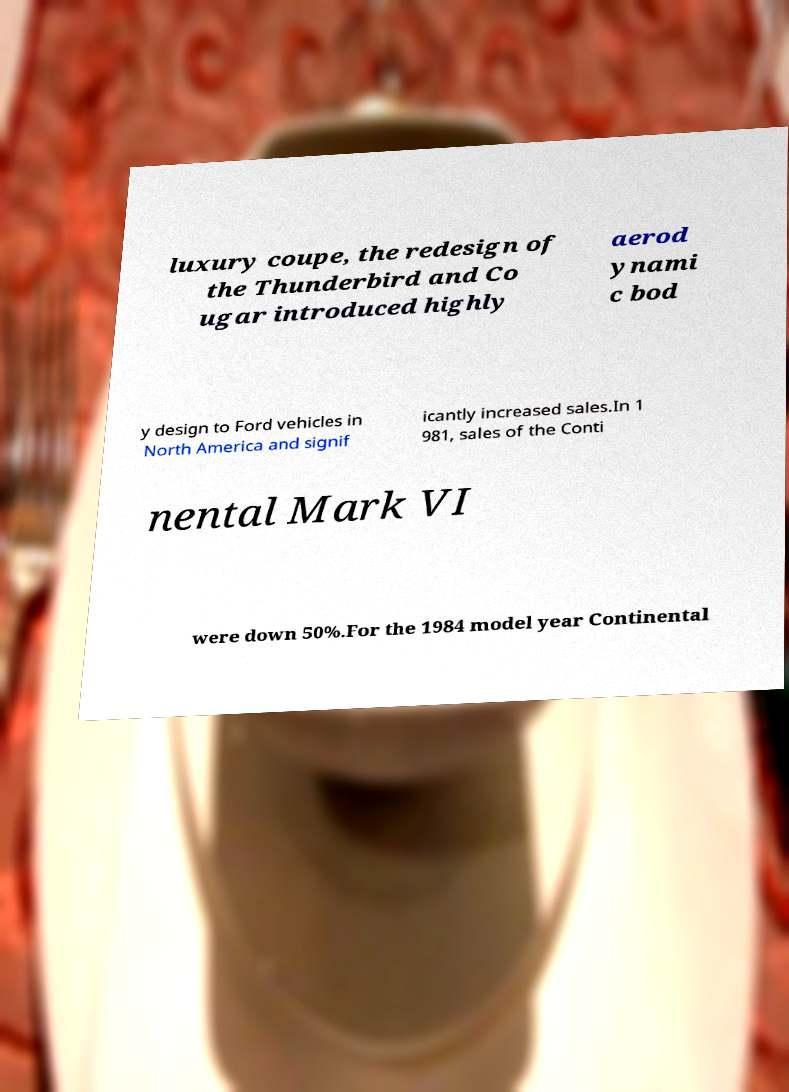I need the written content from this picture converted into text. Can you do that? luxury coupe, the redesign of the Thunderbird and Co ugar introduced highly aerod ynami c bod y design to Ford vehicles in North America and signif icantly increased sales.In 1 981, sales of the Conti nental Mark VI were down 50%.For the 1984 model year Continental 